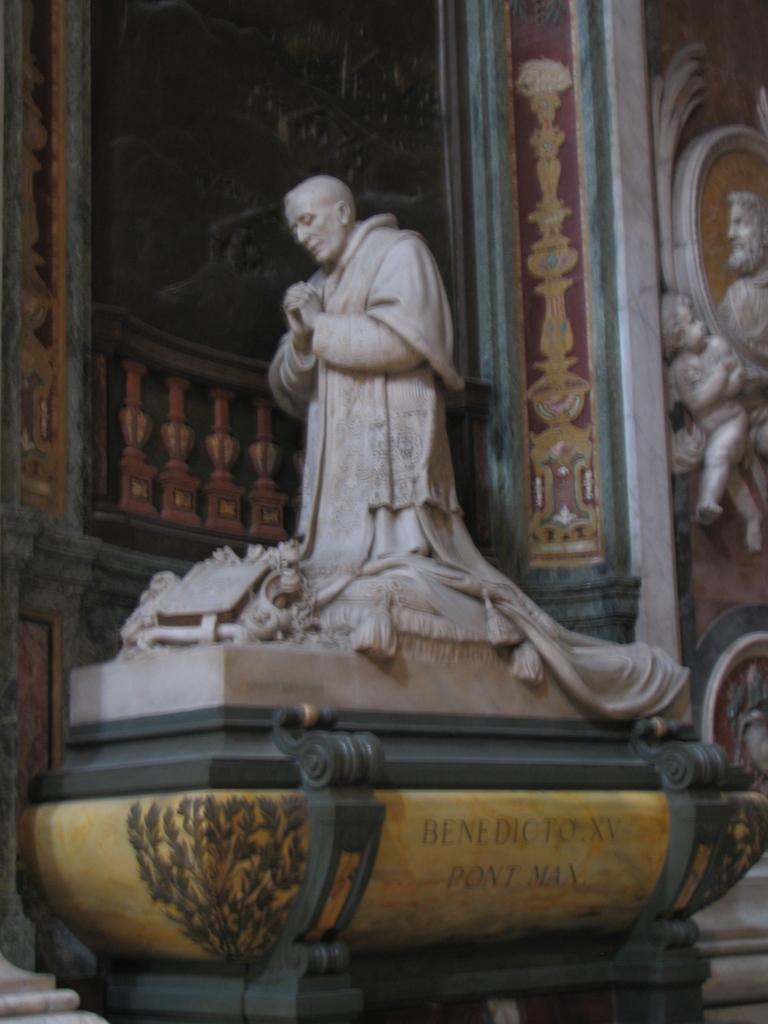Could you give a brief overview of what you see in this image? In this picture in the middle, we can see a statue. In the background, we can see some sculptures and a wall. 